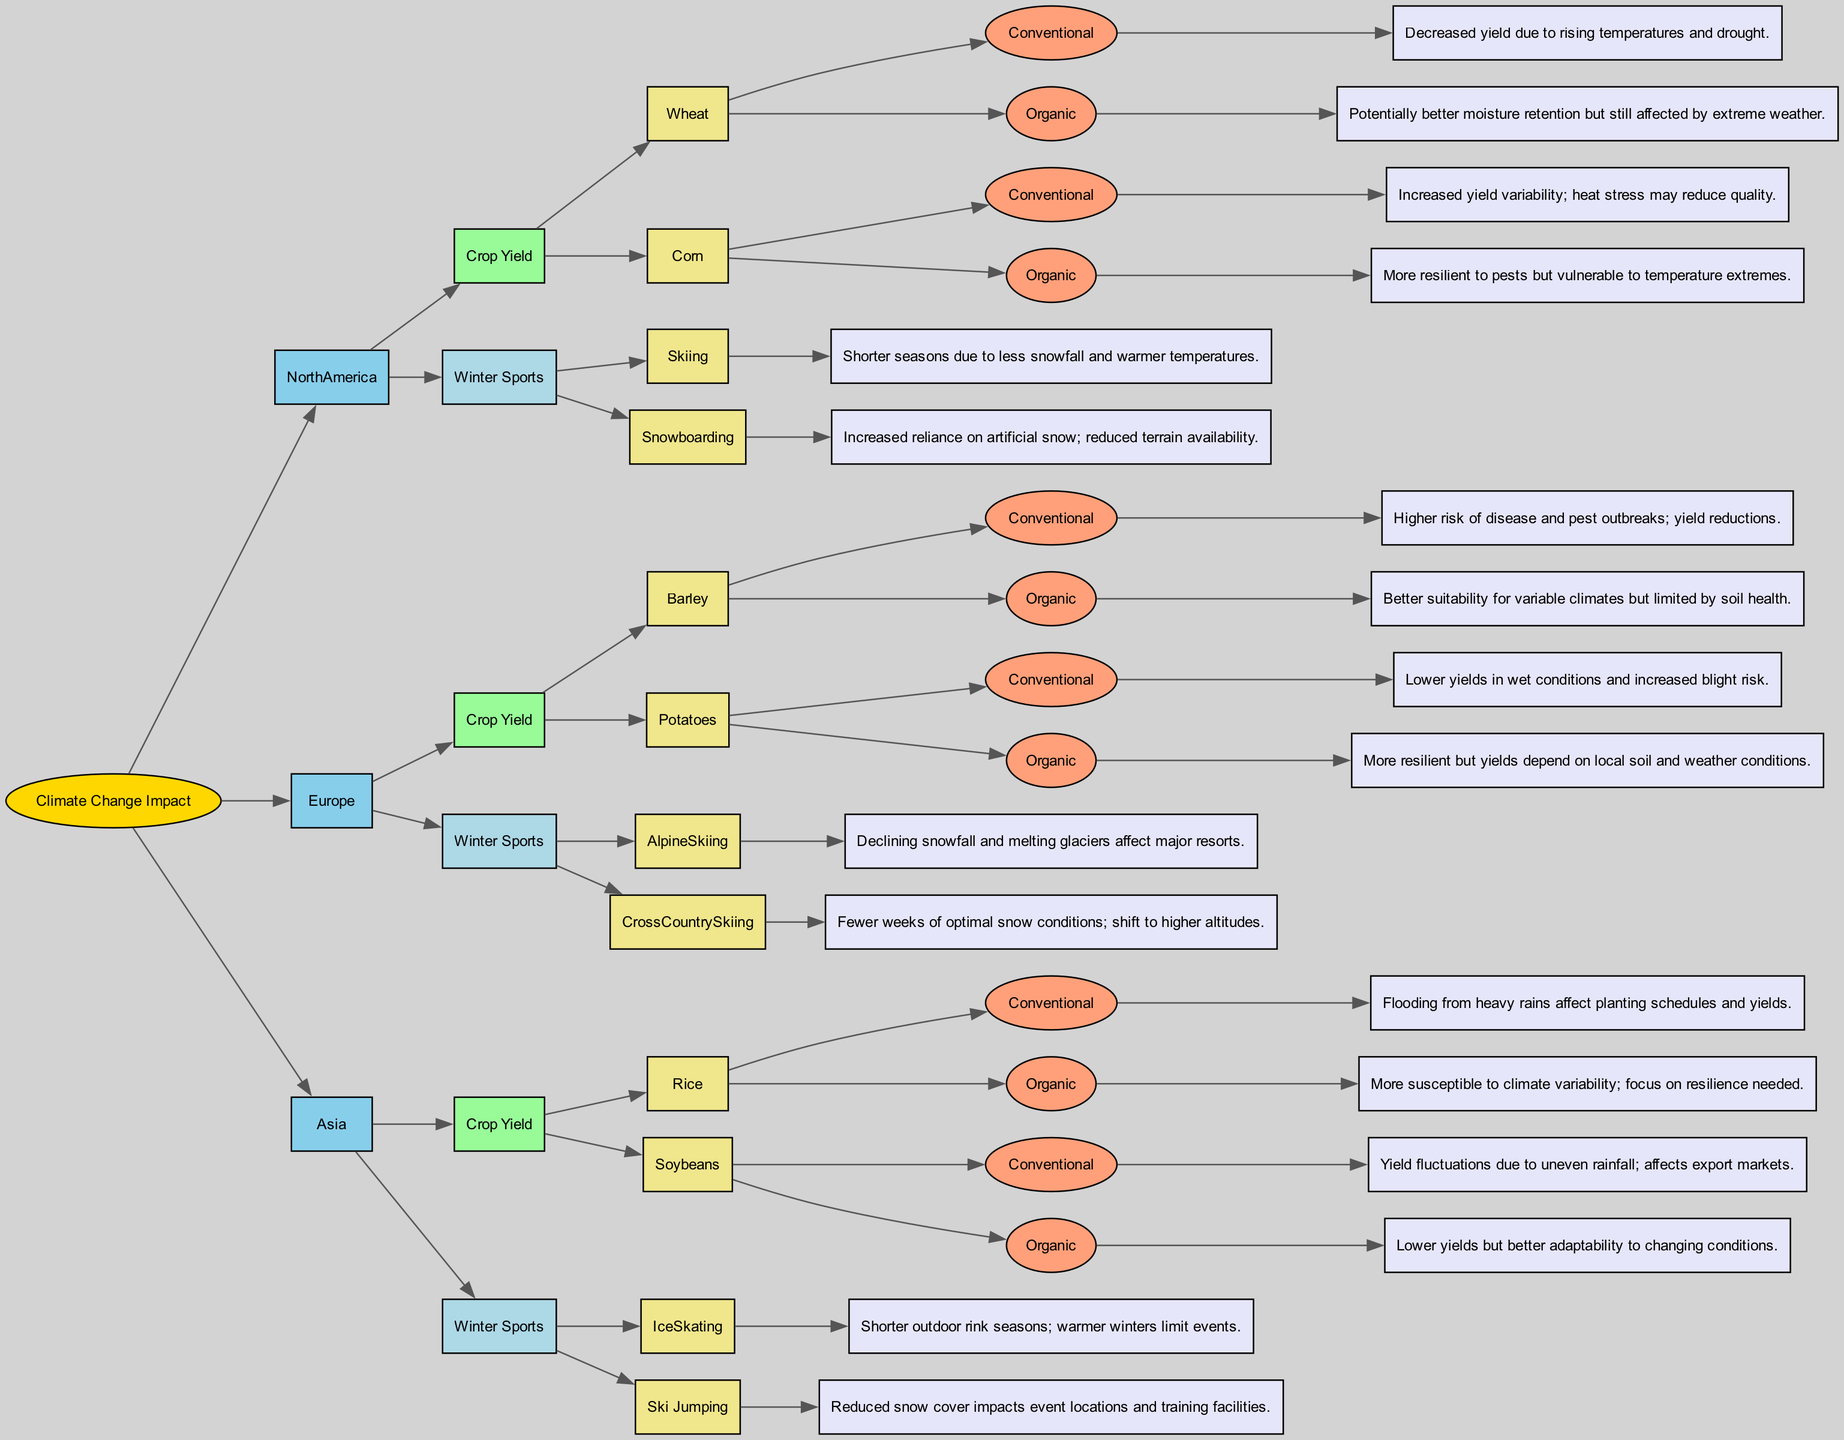What is the primary impact on wheat yield in North America using conventional farming practices? The diagram indicates that the impact on wheat yield in North America under conventional farming practices is “Decreased yield due to rising temperatures and drought.” This can be found by following the node path from North America to Crop Yield, specifically for Wheat, and then to the Conventional farming practices.
Answer: Decreased yield due to rising temperatures and drought Which region shows increased reliance on artificial snow for winter sports? To find this, I trace the node path indicating Winter Sports Conditions, specifically for Snowboarding under North America. The diagram states the impact as "Increased reliance on artificial snow; reduced terrain availability." This details the relationship between reduced natural snow and the consequent adaptation in practices.
Answer: Increased reliance on artificial snow; reduced terrain availability How many crops are analyzed for North America? By examining the node for Crop Yield under North America, I notice there are two crops displayed: Wheat and Corn. Counting these yields a total of two crops.
Answer: 2 What is the environmental change affecting cross-country skiing conditions in Europe? The diagram indicates that cross-country skiing in Europe experiences "Fewer weeks of optimal snow conditions; shift to higher altitudes." I deduce this from following the path from Europe to Winter Sports Conditions, then to Cross-Country Skiing.
Answer: Fewer weeks of optimal snow conditions; shift to higher altitudes What is the impact of organic farming on soybean yield in Asia? The examination of the Crop Yield section for Soybeans in Asia under organic farming practices indicates the impact as "Lower yields but better adaptability to changing conditions." This can be determined by tracing the specific crop and its associated farming practice.
Answer: Lower yields but better adaptability to changing conditions What is a significant challenge for skiing in North America? The impact on skiing conditions in North America is summarized in the node's impact statement: “Shorter seasons due to less snowfall and warmer temperatures.” This information is found by tracing the path to the Winter Sports Conditions specific to Skiing.
Answer: Shorter seasons due to less snowfall and warmer temperatures How does organic farming affect barley yield in Europe? The impact on barley under organic farming practices in Europe is described as "Better suitability for variable climates but limited by soil health." This requires tracing the path for Barley yield under Organic farming practices in Europe.
Answer: Better suitability for variable climates but limited by soil health What farming practice results in higher disease risk for barley yield in Europe? By following the path for Barley yield under Conventional farming practices, the diagram reveals that the impact is "Higher risk of disease and pest outbreaks; yield reductions." Thus, I identify Conventional farming as the practice with higher disease risk.
Answer: Higher risk of disease and pest outbreaks; yield reductions 